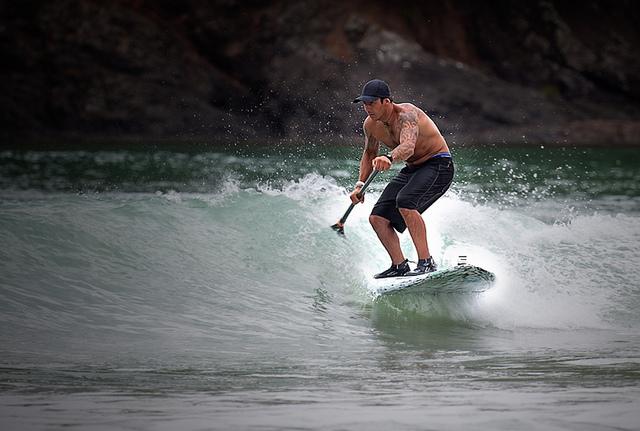What color are his shorts?
Concise answer only. Black. Is the man surfing?
Keep it brief. Yes. Is he sitting down?
Short answer required. No. Is he wearing a shirt?
Concise answer only. No. 